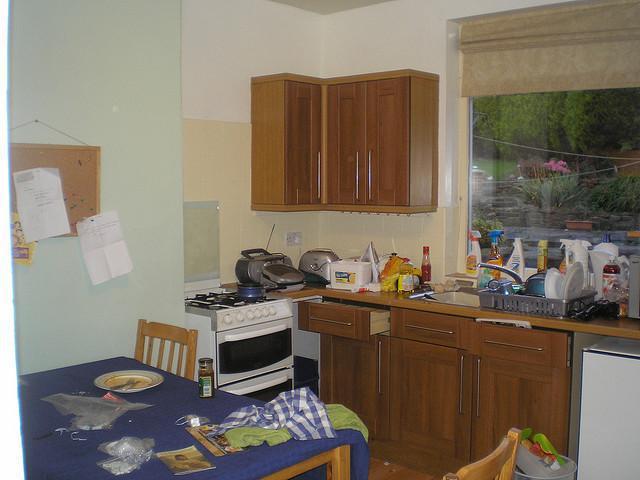How many chairs can you see?
Give a very brief answer. 2. 